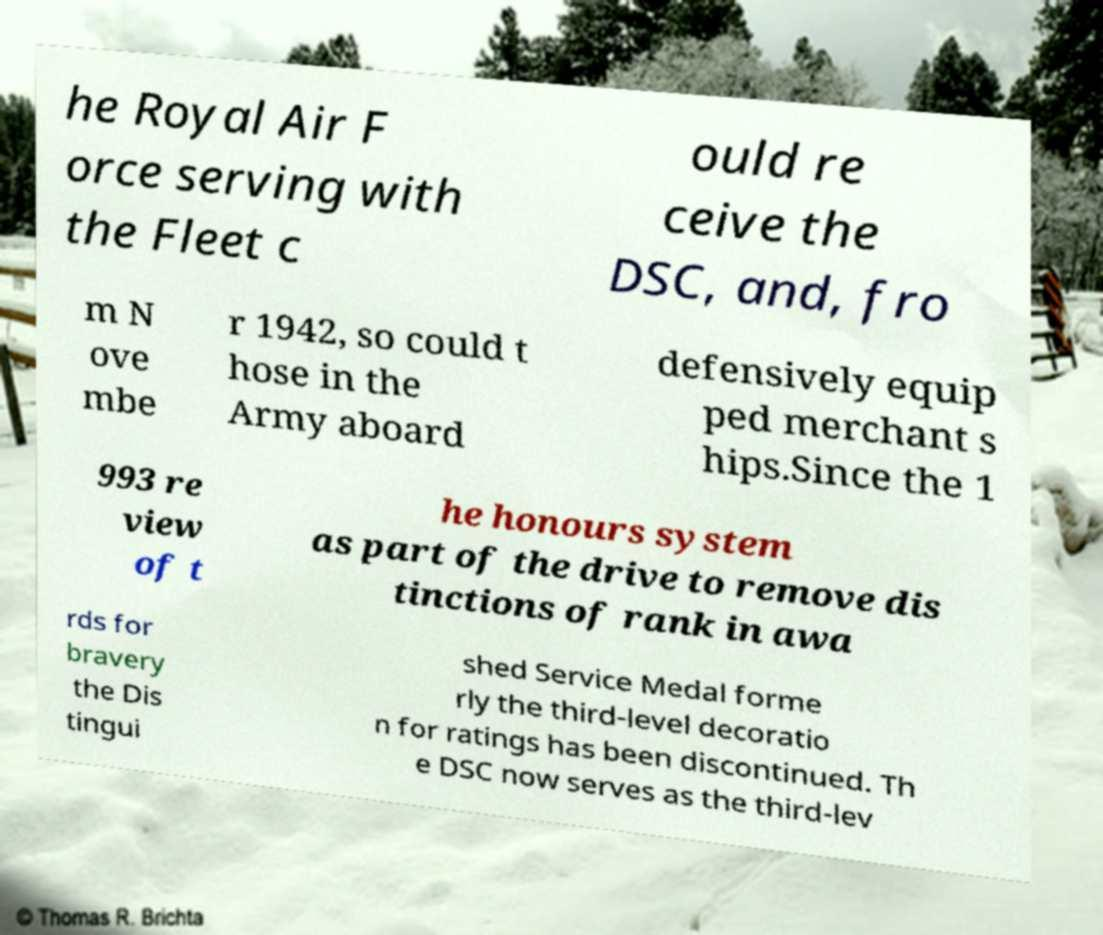There's text embedded in this image that I need extracted. Can you transcribe it verbatim? he Royal Air F orce serving with the Fleet c ould re ceive the DSC, and, fro m N ove mbe r 1942, so could t hose in the Army aboard defensively equip ped merchant s hips.Since the 1 993 re view of t he honours system as part of the drive to remove dis tinctions of rank in awa rds for bravery the Dis tingui shed Service Medal forme rly the third-level decoratio n for ratings has been discontinued. Th e DSC now serves as the third-lev 